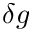Convert formula to latex. <formula><loc_0><loc_0><loc_500><loc_500>\delta g</formula> 